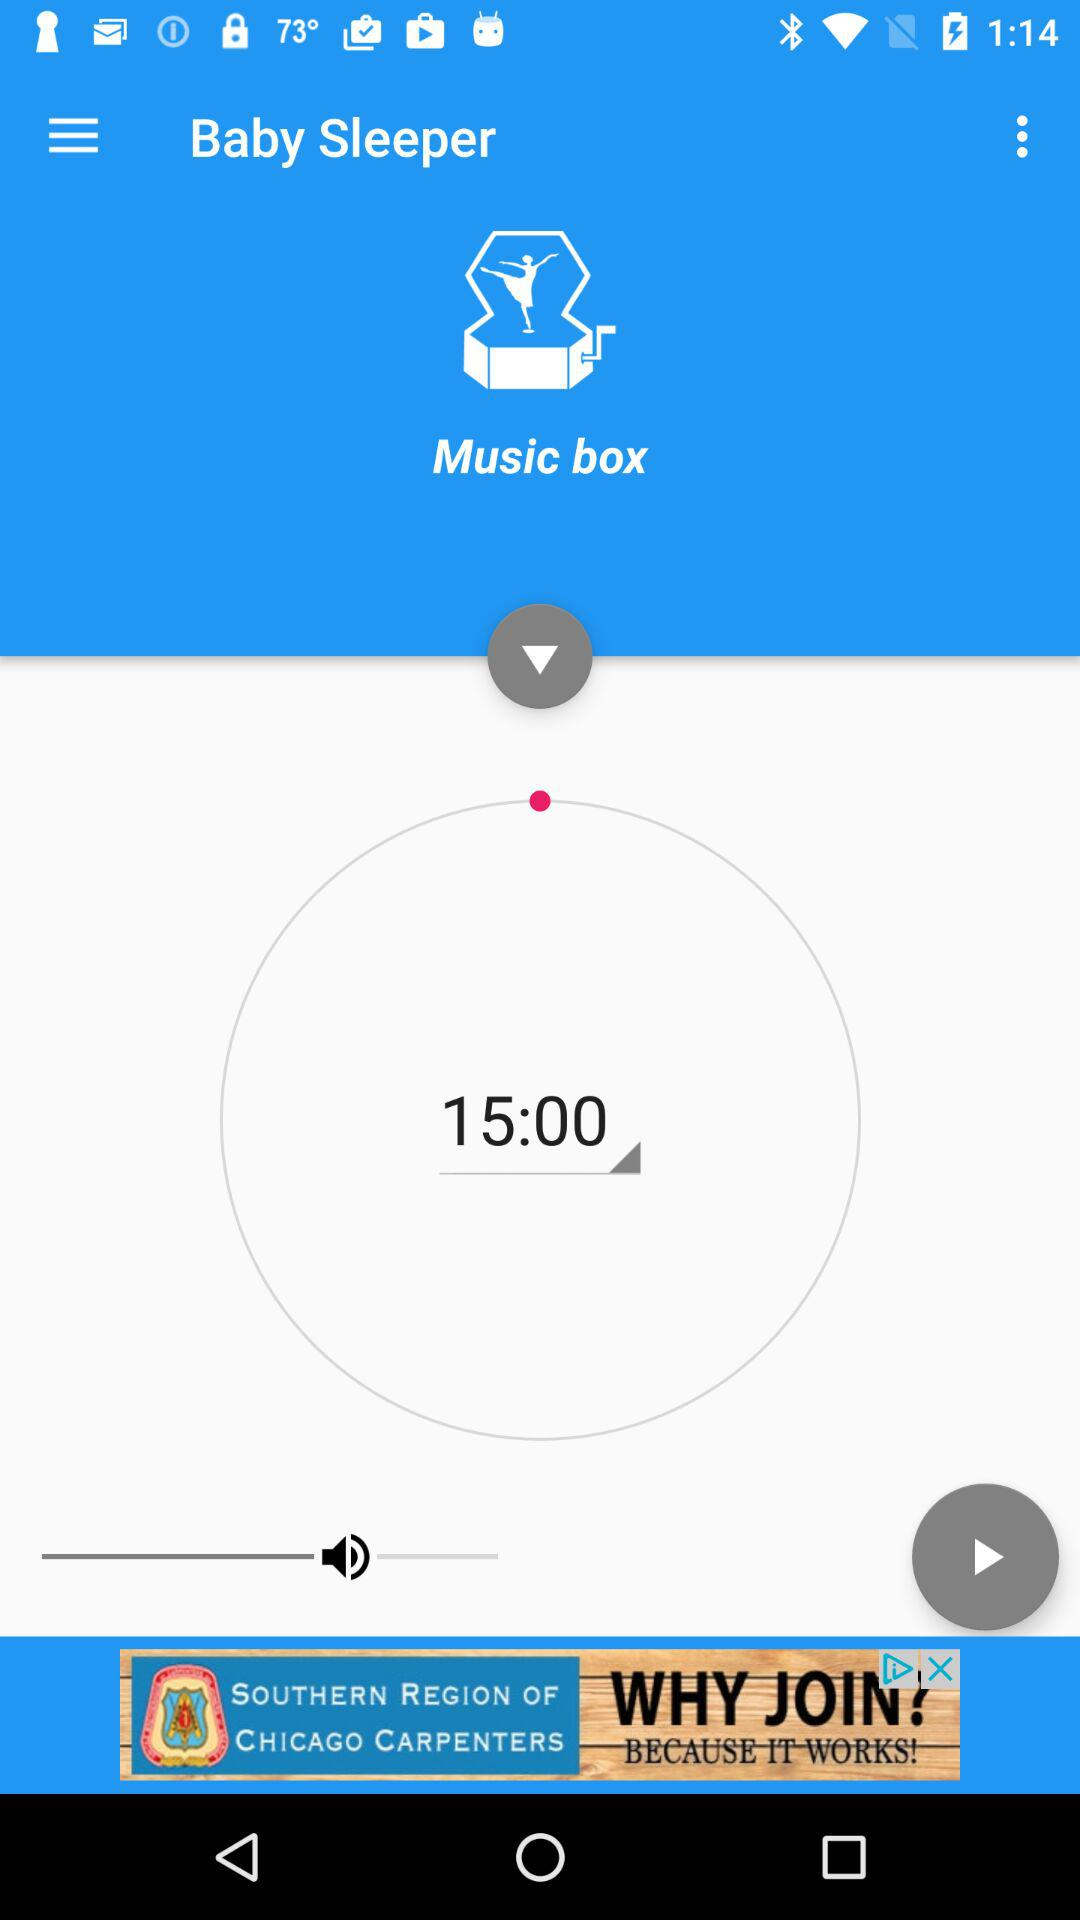What is the name of the application? The name of the application is "Baby Sleeper". 